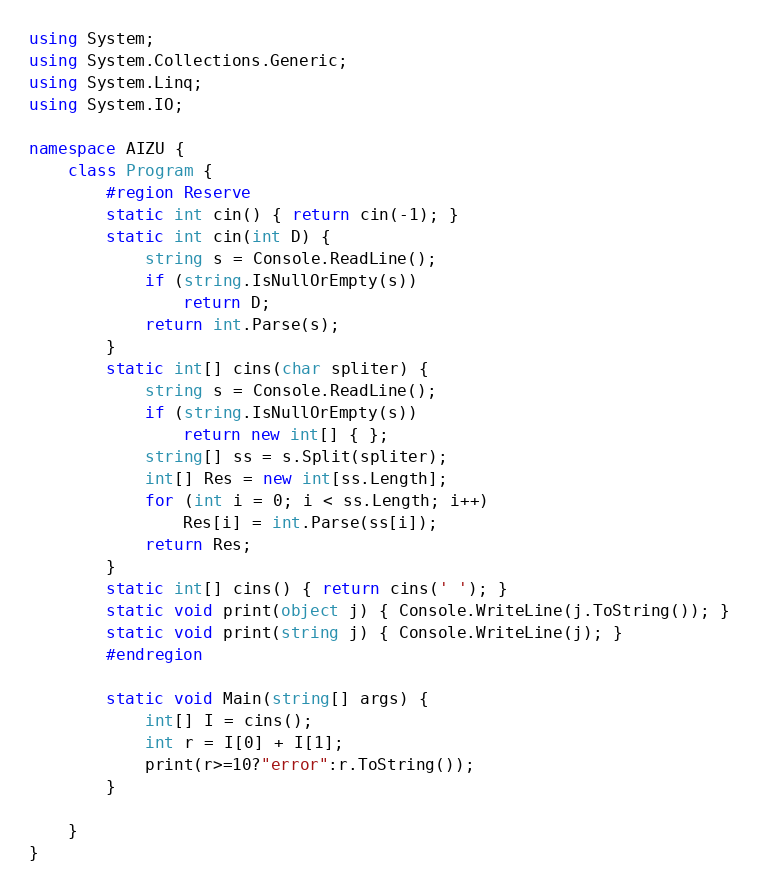Convert code to text. <code><loc_0><loc_0><loc_500><loc_500><_C#_>using System;
using System.Collections.Generic;
using System.Linq;
using System.IO;

namespace AIZU {
	class Program {
		#region Reserve
		static int cin() { return cin(-1); }
		static int cin(int D) {
			string s = Console.ReadLine();
			if (string.IsNullOrEmpty(s))
				return D;
			return int.Parse(s);
		}
		static int[] cins(char spliter) {
			string s = Console.ReadLine();
			if (string.IsNullOrEmpty(s))
				return new int[] { };
			string[] ss = s.Split(spliter);
			int[] Res = new int[ss.Length];
			for (int i = 0; i < ss.Length; i++)
				Res[i] = int.Parse(ss[i]);
			return Res;
		}
		static int[] cins() { return cins(' '); }
		static void print(object j) { Console.WriteLine(j.ToString()); }
		static void print(string j) { Console.WriteLine(j); }
		#endregion
		
		static void Main(string[] args) {
			int[] I = cins();
			int r = I[0] + I[1];
			print(r>=10?"error":r.ToString());
		}
		
	}
}</code> 